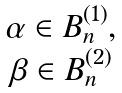<formula> <loc_0><loc_0><loc_500><loc_500>\begin{matrix} \alpha \in B _ { n } ^ { ( 1 ) } , \\ \beta \in B _ { n } ^ { ( 2 ) } \end{matrix}</formula> 